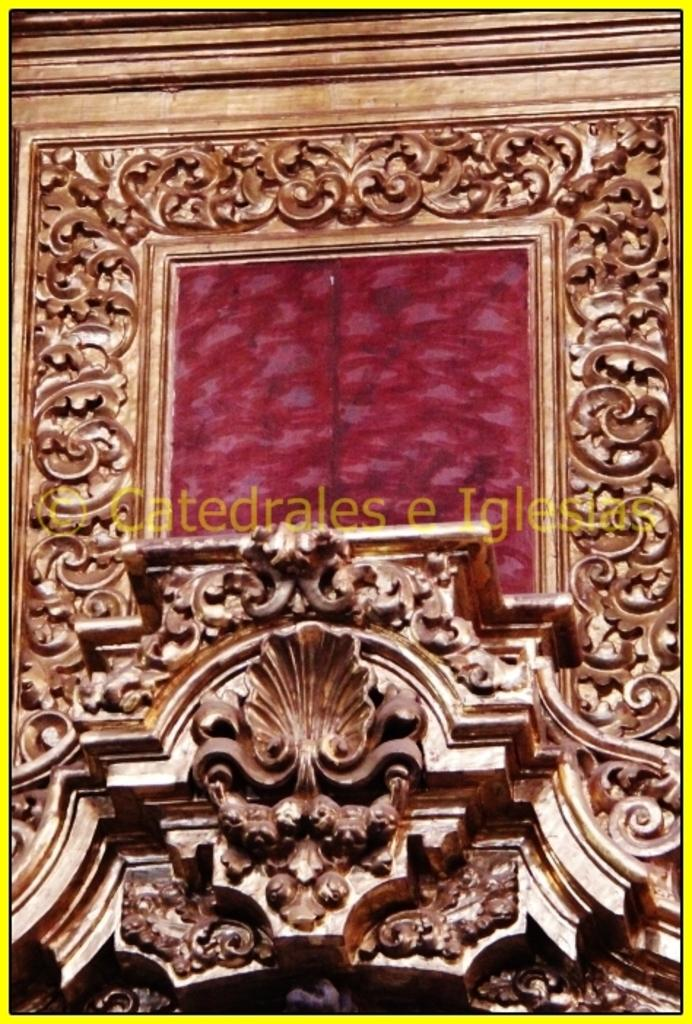<image>
Describe the image concisely. An ornate golden architectural feature has been documented by Catedrales e Iglesias. 